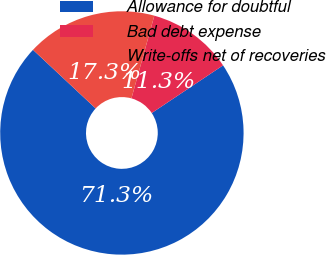Convert chart. <chart><loc_0><loc_0><loc_500><loc_500><pie_chart><fcel>Allowance for doubtful<fcel>Bad debt expense<fcel>Write-offs net of recoveries<nl><fcel>71.35%<fcel>11.33%<fcel>17.33%<nl></chart> 